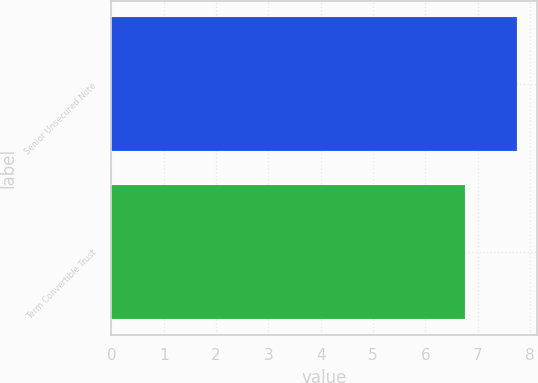Convert chart. <chart><loc_0><loc_0><loc_500><loc_500><bar_chart><fcel>Senior Unsecured Note<fcel>Term Convertible Trust<nl><fcel>7.75<fcel>6.75<nl></chart> 